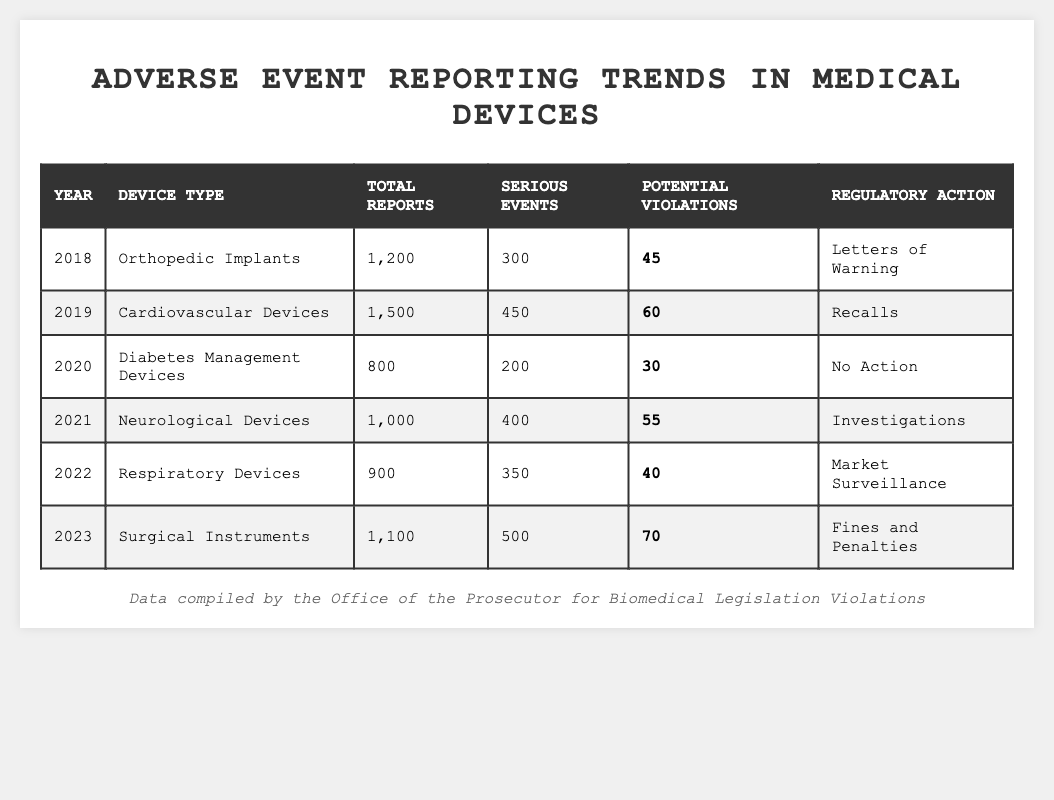What was the total number of reports for Orthopedic Implants in 2018? The table states that in 2018, the total number of reports for Orthopedic Implants was listed as 1,200.
Answer: 1,200 How many serious events were reported for Cardiovascular Devices in 2019? According to the table, there were 450 serious events reported for Cardiovascular Devices in 2019.
Answer: 450 Which year saw the highest number of potential violations? By comparing the "Potential Violations" column, the year 2023 shows the highest number with 70 potential violations.
Answer: 2023 What is the regulatory action taken for Diabetes Management Devices in 2020? The table indicates that no regulatory action was taken for Diabetes Management Devices in 2020.
Answer: No Action What is the difference in total reports between Cardiovascular Devices in 2019 and Surgical Instruments in 2023? Cardiovascular Devices had 1,500 total reports in 2019 and Surgical Instruments had 1,100 in 2023. The difference is 1,500 - 1,100 = 400.
Answer: 400 Was there a decrease in serious events from 2018 to 2022 for any device type? Yes, comparing the serious events: Orthopedic Implants (300) to Respiratory Devices (350) shows an increase, but not a decrease. However, the only decrease in serious events for devices occurred from 2019 (450) to 2020 (200).
Answer: Yes What percentage of total reports in 2021 were serious events? In 2021, there were 1,000 total reports and 400 serious events. To find the percentage: (400 / 1,000) * 100 = 40%.
Answer: 40% Which device type had the least serious events reported, and what was the number? The Diabetes Management Devices in 2020 had the least serious events reported at 200.
Answer: Diabetes Management Devices, 200 How does the potential violations in 2022 compare with 2019? In 2019, there were 60 potential violations for Cardiovascular Devices and in 2022, there were 40 for Respiratory Devices. Since 40 < 60, there was a decrease.
Answer: Decrease What was the total number of reports across all years summarized in the table? By adding the total reports: 1,200 + 1,500 + 800 + 1,000 + 900 + 1,100 = 6,500.
Answer: 6,500 Did the regulatory action for Neurological Devices in 2021 lead to serious events being reported? The regulatory action was investigations, which correlated with 400 serious events reported, indicating that the action did lead to serious events being documented.
Answer: Yes 